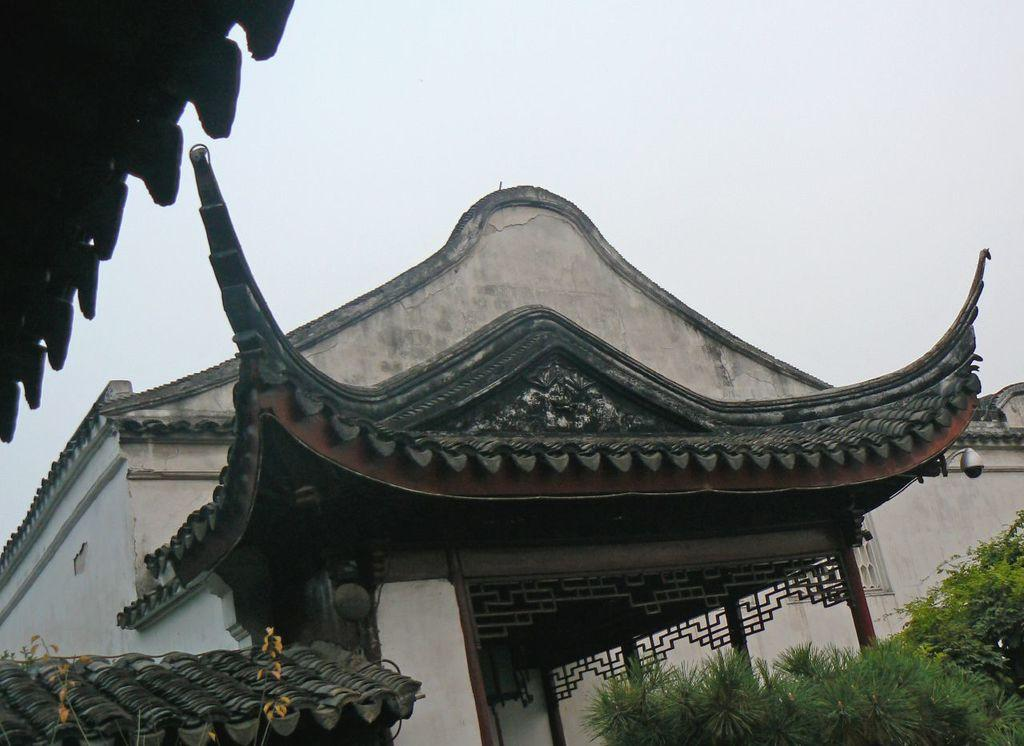What type of building is visible in the image? There is a house in the image. Where are the plants located in the image? The plants are in the bottom right corner of the image. What part of the house is visible in the top left corner of the image? The roof is visible in the top left corner of the image. What can be seen in the background of the image? The sky is visible in the background of the image. How many brothers are playing in the yard in the image? There are no brothers or yard visible in the image; it features a house with plants, a roof, and the sky in the background. 